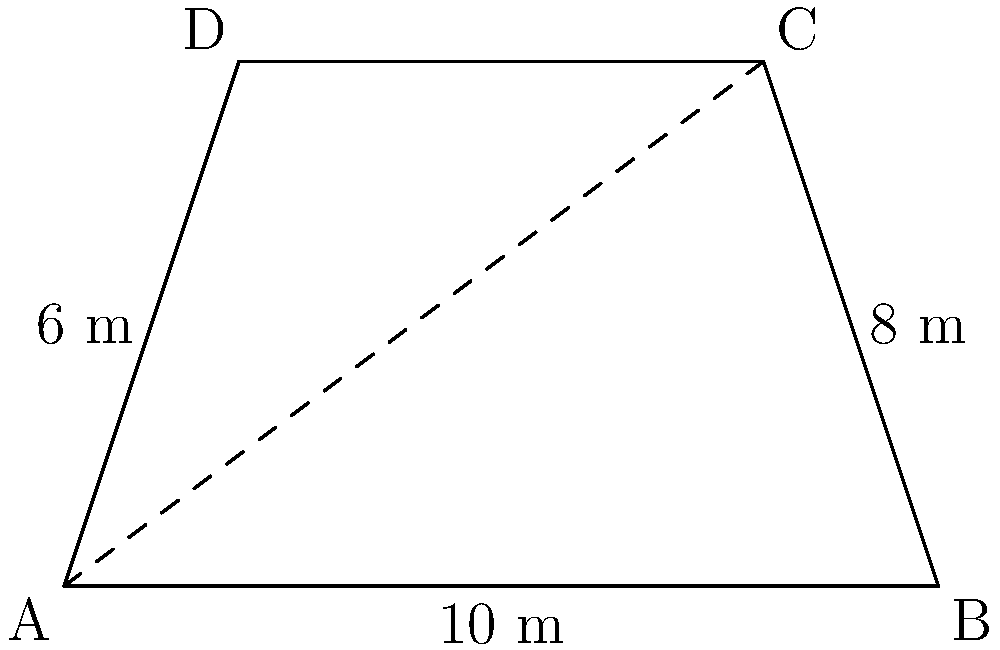As part of the film festival's outdoor screening setup, you need to calculate the area of a trapezoid-shaped movie screen. The screen has a base width of 10 meters, a top width of 8 meters, and a height of 6 meters. What is the area of the screen in square meters? To find the area of a trapezoid, we use the formula:

$$A = \frac{1}{2}(b_1 + b_2)h$$

Where:
$A$ = Area
$b_1$ = Length of one parallel side
$b_2$ = Length of the other parallel side
$h$ = Height (perpendicular distance between the parallel sides)

Given:
$b_1 = 10$ m (base width)
$b_2 = 8$ m (top width)
$h = 6$ m (height)

Let's substitute these values into the formula:

$$A = \frac{1}{2}(10 + 8) \times 6$$

$$A = \frac{1}{2}(18) \times 6$$

$$A = 9 \times 6$$

$$A = 54$$

Therefore, the area of the trapezoid-shaped movie screen is 54 square meters.
Answer: 54 m² 